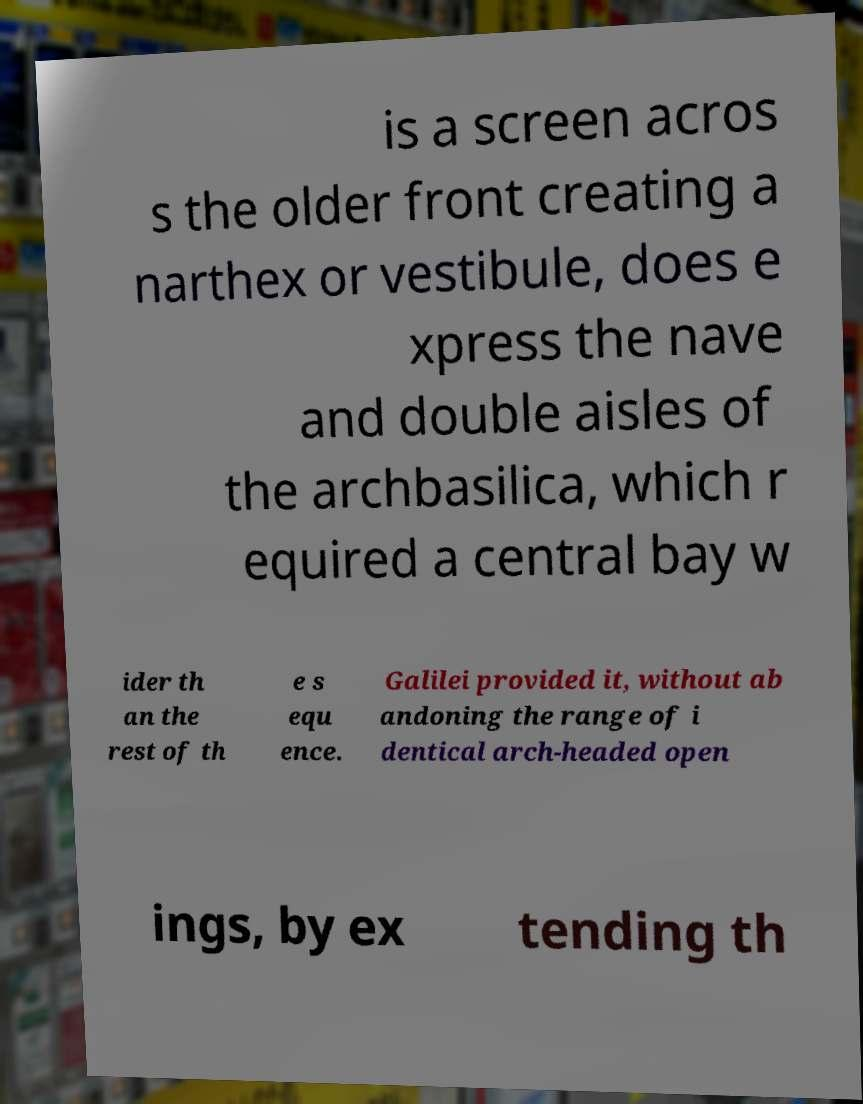Could you extract and type out the text from this image? is a screen acros s the older front creating a narthex or vestibule, does e xpress the nave and double aisles of the archbasilica, which r equired a central bay w ider th an the rest of th e s equ ence. Galilei provided it, without ab andoning the range of i dentical arch-headed open ings, by ex tending th 